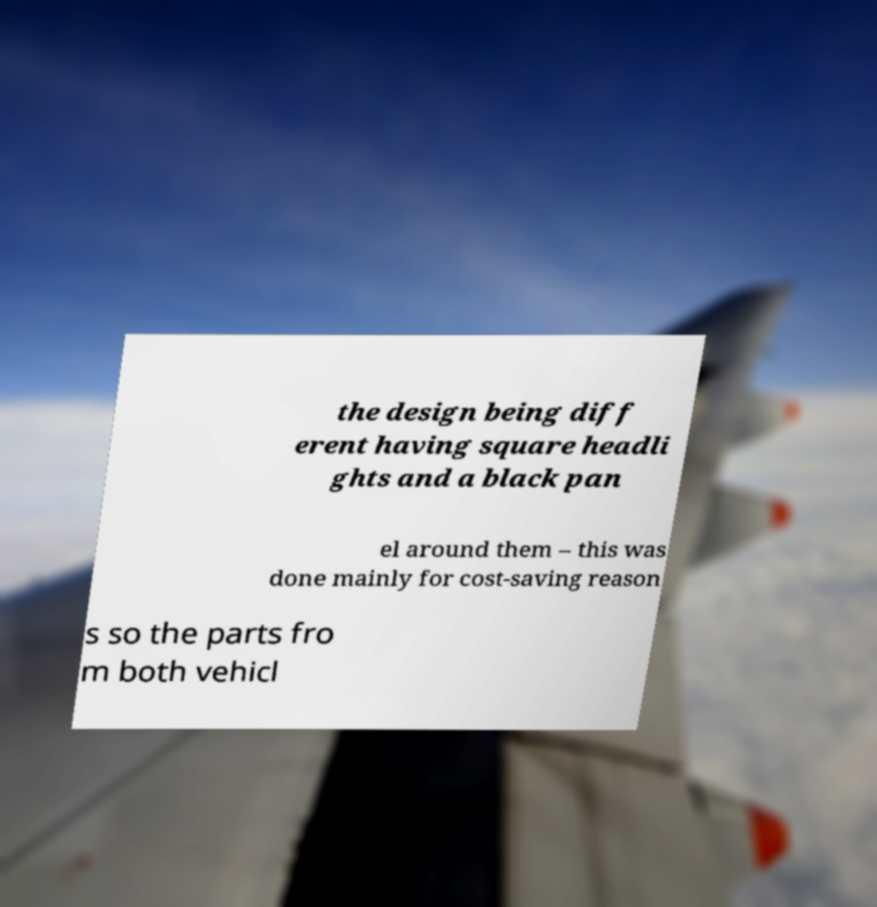Could you assist in decoding the text presented in this image and type it out clearly? the design being diff erent having square headli ghts and a black pan el around them – this was done mainly for cost-saving reason s so the parts fro m both vehicl 